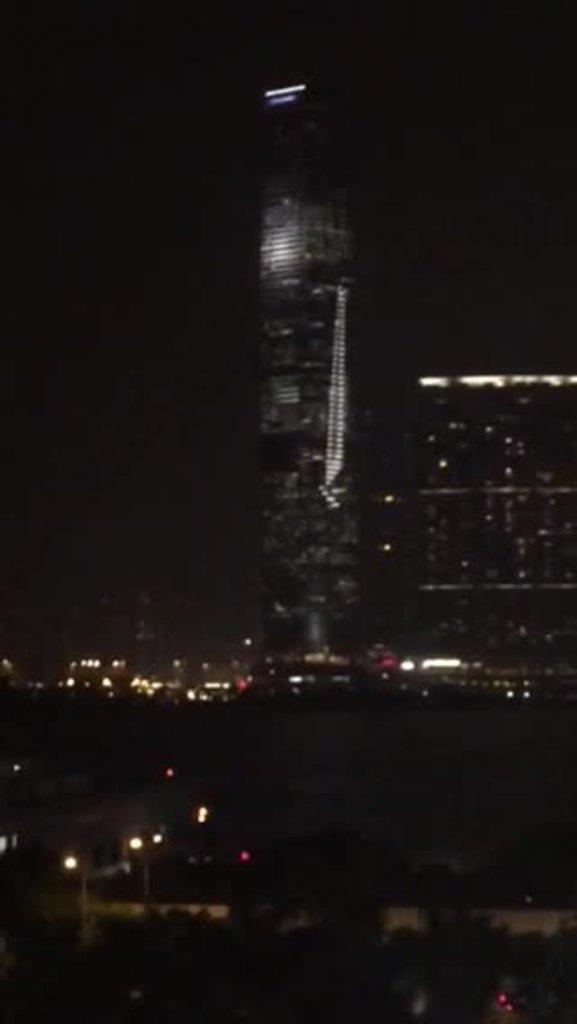What time of day is depicted in the image? The image is set during night time. What type of structures can be seen in the image? There are big buildings in the image. What feature do the buildings have at the top? The buildings have lights at the top. What part of the natural environment is visible in the image? The sky is visible in the image. What type of battle is taking place in the image? There is no battle present in the image; it features big buildings with lights at the top during night time. What is the interest rate for the loan mentioned in the image? There is no mention of a loan or interest rate in the image. 